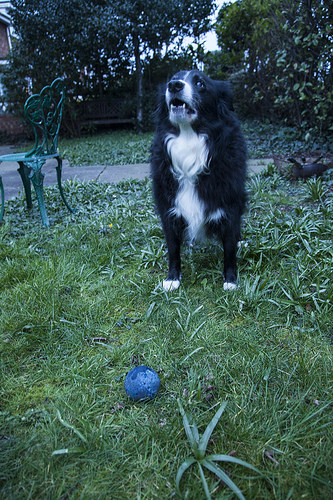<image>
Is the ball under the dog? No. The ball is not positioned under the dog. The vertical relationship between these objects is different. 